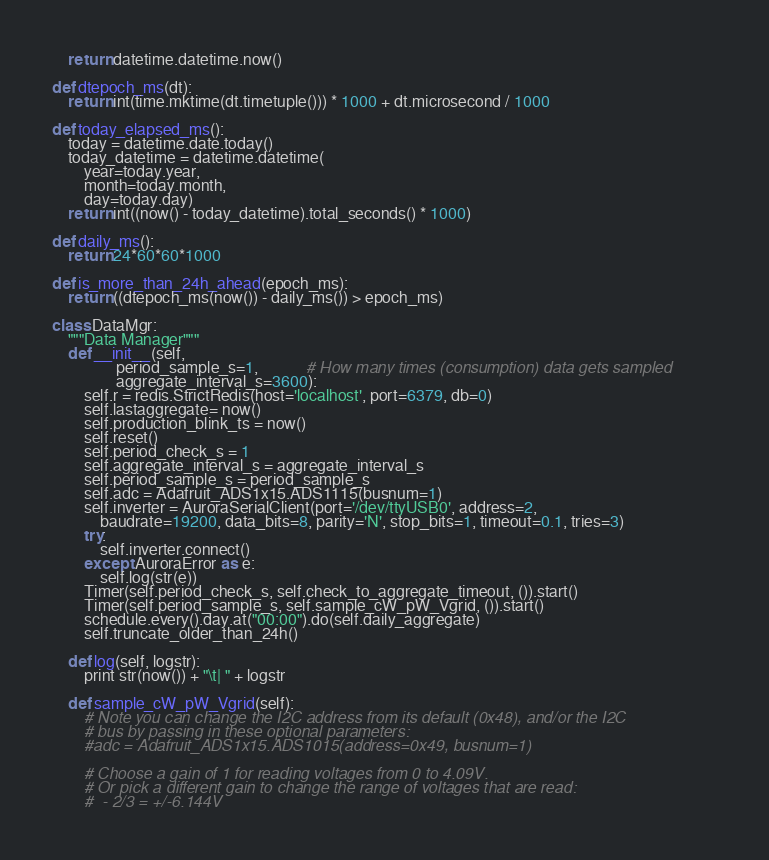<code> <loc_0><loc_0><loc_500><loc_500><_Python_>	return datetime.datetime.now()

def dtepoch_ms(dt):
	return int(time.mktime(dt.timetuple())) * 1000 + dt.microsecond / 1000

def today_elapsed_ms():
	today = datetime.date.today()
	today_datetime = datetime.datetime(
	    year=today.year, 
	    month=today.month,
	    day=today.day)
	return int((now() - today_datetime).total_seconds() * 1000)

def daily_ms():
	return 24*60*60*1000

def is_more_than_24h_ahead(epoch_ms):
	return ((dtepoch_ms(now()) - daily_ms()) > epoch_ms)   

class DataMgr:
	"""Data Manager"""
	def __init__(self, 
				period_sample_s=1, 			# How many times (consumption) data gets sampled  			
				aggregate_interval_s=3600):
		self.r = redis.StrictRedis(host='localhost', port=6379, db=0)
		self.lastaggregate= now()
		self.production_blink_ts = now()
		self.reset()
		self.period_check_s = 1
		self.aggregate_interval_s = aggregate_interval_s
		self.period_sample_s = period_sample_s
		self.adc = Adafruit_ADS1x15.ADS1115(busnum=1)
		self.inverter = AuroraSerialClient(port='/dev/ttyUSB0', address=2, 
			baudrate=19200, data_bits=8, parity='N', stop_bits=1, timeout=0.1, tries=3)
		try:
			self.inverter.connect()
		except AuroraError as e:
			self.log(str(e))
		Timer(self.period_check_s, self.check_to_aggregate_timeout, ()).start()
		Timer(self.period_sample_s, self.sample_cW_pW_Vgrid, ()).start()
		schedule.every().day.at("00:00").do(self.daily_aggregate)
		self.truncate_older_than_24h()

	def log(self, logstr):
		print str(now()) + "\t| " + logstr

	def sample_cW_pW_Vgrid(self):
		# Note you can change the I2C address from its default (0x48), and/or the I2C
		# bus by passing in these optional parameters:
		#adc = Adafruit_ADS1x15.ADS1015(address=0x49, busnum=1)

		# Choose a gain of 1 for reading voltages from 0 to 4.09V.
		# Or pick a different gain to change the range of voltages that are read:
		#  - 2/3 = +/-6.144V</code> 